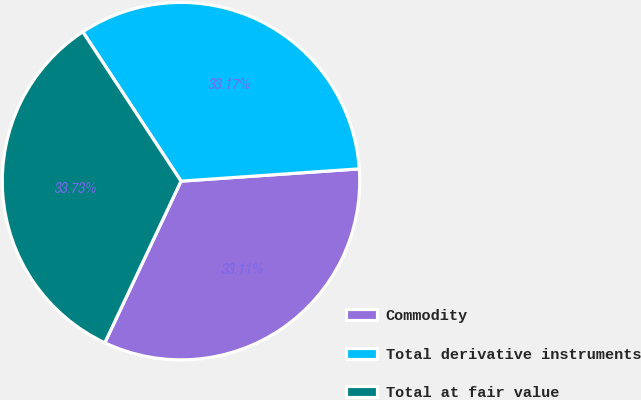Convert chart. <chart><loc_0><loc_0><loc_500><loc_500><pie_chart><fcel>Commodity<fcel>Total derivative instruments<fcel>Total at fair value<nl><fcel>33.11%<fcel>33.17%<fcel>33.73%<nl></chart> 